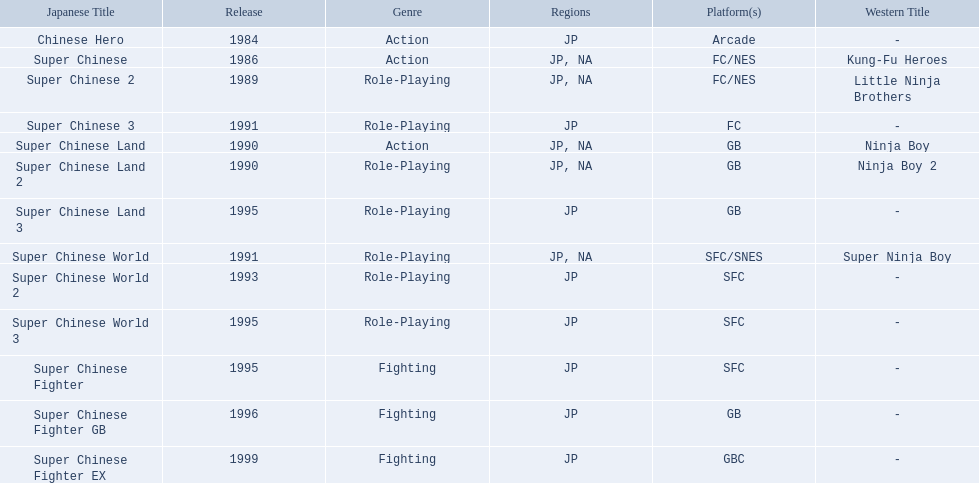Super ninja world was released in what countries? JP, NA. What was the original name for this title? Super Chinese World. 